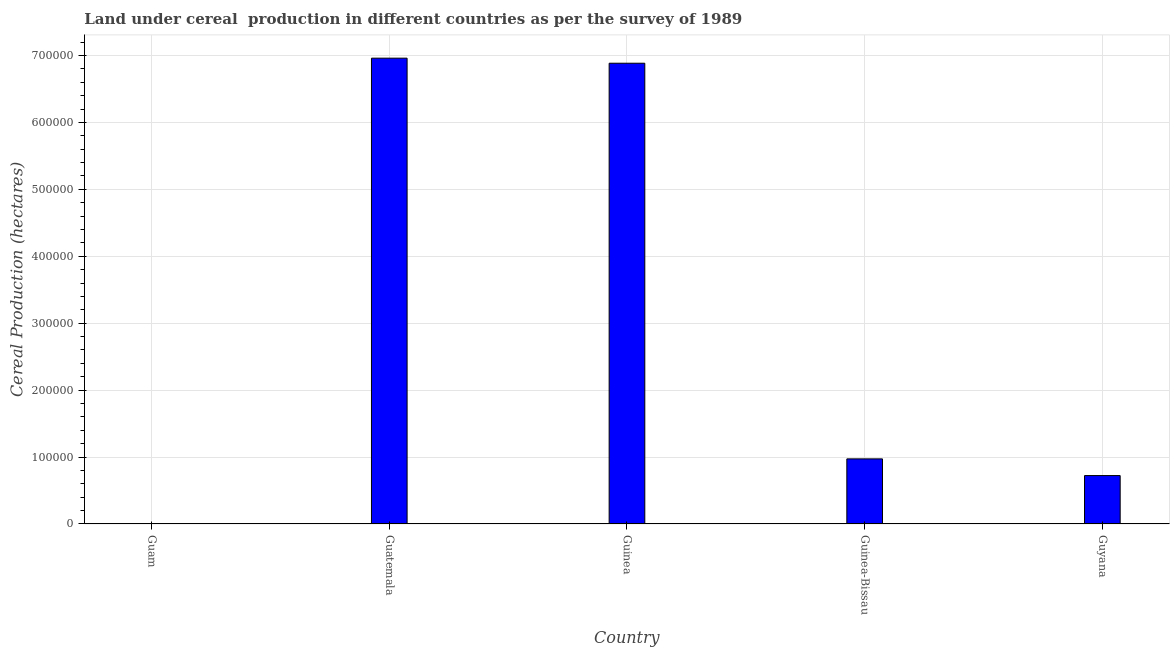What is the title of the graph?
Provide a short and direct response. Land under cereal  production in different countries as per the survey of 1989. What is the label or title of the Y-axis?
Offer a terse response. Cereal Production (hectares). What is the land under cereal production in Guyana?
Your answer should be compact. 7.23e+04. Across all countries, what is the maximum land under cereal production?
Offer a terse response. 6.96e+05. Across all countries, what is the minimum land under cereal production?
Your response must be concise. 10. In which country was the land under cereal production maximum?
Your answer should be very brief. Guatemala. In which country was the land under cereal production minimum?
Ensure brevity in your answer.  Guam. What is the sum of the land under cereal production?
Keep it short and to the point. 1.55e+06. What is the difference between the land under cereal production in Guam and Guyana?
Your answer should be very brief. -7.23e+04. What is the average land under cereal production per country?
Provide a succinct answer. 3.11e+05. What is the median land under cereal production?
Your answer should be very brief. 9.73e+04. In how many countries, is the land under cereal production greater than 120000 hectares?
Offer a terse response. 2. What is the ratio of the land under cereal production in Guinea to that in Guinea-Bissau?
Keep it short and to the point. 7.08. Is the difference between the land under cereal production in Guatemala and Guinea-Bissau greater than the difference between any two countries?
Provide a succinct answer. No. What is the difference between the highest and the second highest land under cereal production?
Your response must be concise. 7566. Is the sum of the land under cereal production in Guinea and Guinea-Bissau greater than the maximum land under cereal production across all countries?
Keep it short and to the point. Yes. What is the difference between the highest and the lowest land under cereal production?
Your answer should be compact. 6.96e+05. In how many countries, is the land under cereal production greater than the average land under cereal production taken over all countries?
Give a very brief answer. 2. What is the difference between two consecutive major ticks on the Y-axis?
Keep it short and to the point. 1.00e+05. Are the values on the major ticks of Y-axis written in scientific E-notation?
Your answer should be very brief. No. What is the Cereal Production (hectares) in Guam?
Your answer should be compact. 10. What is the Cereal Production (hectares) in Guatemala?
Offer a very short reply. 6.96e+05. What is the Cereal Production (hectares) of Guinea?
Your answer should be compact. 6.88e+05. What is the Cereal Production (hectares) in Guinea-Bissau?
Your response must be concise. 9.73e+04. What is the Cereal Production (hectares) of Guyana?
Your response must be concise. 7.23e+04. What is the difference between the Cereal Production (hectares) in Guam and Guatemala?
Your answer should be very brief. -6.96e+05. What is the difference between the Cereal Production (hectares) in Guam and Guinea?
Provide a succinct answer. -6.88e+05. What is the difference between the Cereal Production (hectares) in Guam and Guinea-Bissau?
Provide a short and direct response. -9.73e+04. What is the difference between the Cereal Production (hectares) in Guam and Guyana?
Your answer should be very brief. -7.23e+04. What is the difference between the Cereal Production (hectares) in Guatemala and Guinea?
Give a very brief answer. 7566. What is the difference between the Cereal Production (hectares) in Guatemala and Guinea-Bissau?
Offer a terse response. 5.99e+05. What is the difference between the Cereal Production (hectares) in Guatemala and Guyana?
Provide a succinct answer. 6.24e+05. What is the difference between the Cereal Production (hectares) in Guinea and Guinea-Bissau?
Ensure brevity in your answer.  5.91e+05. What is the difference between the Cereal Production (hectares) in Guinea and Guyana?
Give a very brief answer. 6.16e+05. What is the difference between the Cereal Production (hectares) in Guinea-Bissau and Guyana?
Give a very brief answer. 2.49e+04. What is the ratio of the Cereal Production (hectares) in Guam to that in Guatemala?
Keep it short and to the point. 0. What is the ratio of the Cereal Production (hectares) in Guam to that in Guinea-Bissau?
Keep it short and to the point. 0. What is the ratio of the Cereal Production (hectares) in Guam to that in Guyana?
Your answer should be compact. 0. What is the ratio of the Cereal Production (hectares) in Guatemala to that in Guinea-Bissau?
Provide a short and direct response. 7.16. What is the ratio of the Cereal Production (hectares) in Guatemala to that in Guyana?
Your answer should be very brief. 9.62. What is the ratio of the Cereal Production (hectares) in Guinea to that in Guinea-Bissau?
Your answer should be compact. 7.08. What is the ratio of the Cereal Production (hectares) in Guinea to that in Guyana?
Offer a terse response. 9.52. What is the ratio of the Cereal Production (hectares) in Guinea-Bissau to that in Guyana?
Ensure brevity in your answer.  1.34. 